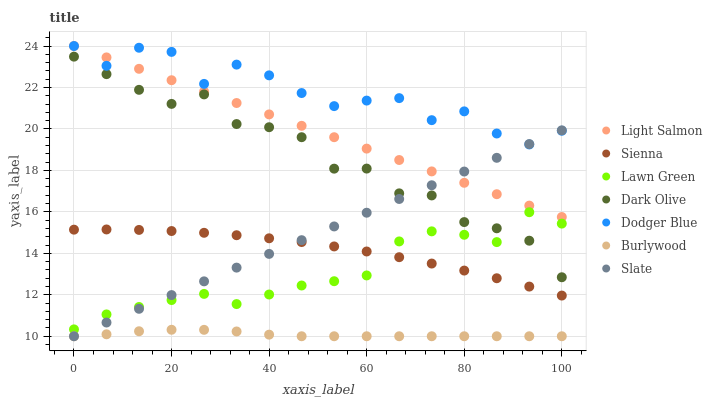Does Burlywood have the minimum area under the curve?
Answer yes or no. Yes. Does Dodger Blue have the maximum area under the curve?
Answer yes or no. Yes. Does Light Salmon have the minimum area under the curve?
Answer yes or no. No. Does Light Salmon have the maximum area under the curve?
Answer yes or no. No. Is Light Salmon the smoothest?
Answer yes or no. Yes. Is Dodger Blue the roughest?
Answer yes or no. Yes. Is Burlywood the smoothest?
Answer yes or no. No. Is Burlywood the roughest?
Answer yes or no. No. Does Burlywood have the lowest value?
Answer yes or no. Yes. Does Light Salmon have the lowest value?
Answer yes or no. No. Does Dodger Blue have the highest value?
Answer yes or no. Yes. Does Burlywood have the highest value?
Answer yes or no. No. Is Lawn Green less than Light Salmon?
Answer yes or no. Yes. Is Light Salmon greater than Dark Olive?
Answer yes or no. Yes. Does Dodger Blue intersect Slate?
Answer yes or no. Yes. Is Dodger Blue less than Slate?
Answer yes or no. No. Is Dodger Blue greater than Slate?
Answer yes or no. No. Does Lawn Green intersect Light Salmon?
Answer yes or no. No. 